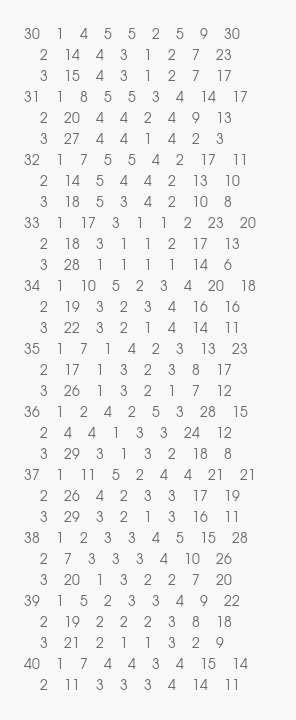<code> <loc_0><loc_0><loc_500><loc_500><_ObjectiveC_>30	1	4	5	5	2	5	9	30	
	2	14	4	3	1	2	7	23	
	3	15	4	3	1	2	7	17	
31	1	8	5	5	3	4	14	17	
	2	20	4	4	2	4	9	13	
	3	27	4	4	1	4	2	3	
32	1	7	5	5	4	2	17	11	
	2	14	5	4	4	2	13	10	
	3	18	5	3	4	2	10	8	
33	1	17	3	1	1	2	23	20	
	2	18	3	1	1	2	17	13	
	3	28	1	1	1	1	14	6	
34	1	10	5	2	3	4	20	18	
	2	19	3	2	3	4	16	16	
	3	22	3	2	1	4	14	11	
35	1	7	1	4	2	3	13	23	
	2	17	1	3	2	3	8	17	
	3	26	1	3	2	1	7	12	
36	1	2	4	2	5	3	28	15	
	2	4	4	1	3	3	24	12	
	3	29	3	1	3	2	18	8	
37	1	11	5	2	4	4	21	21	
	2	26	4	2	3	3	17	19	
	3	29	3	2	1	3	16	11	
38	1	2	3	3	4	5	15	28	
	2	7	3	3	3	4	10	26	
	3	20	1	3	2	2	7	20	
39	1	5	2	3	3	4	9	22	
	2	19	2	2	2	3	8	18	
	3	21	2	1	1	3	2	9	
40	1	7	4	4	3	4	15	14	
	2	11	3	3	3	4	14	11	</code> 